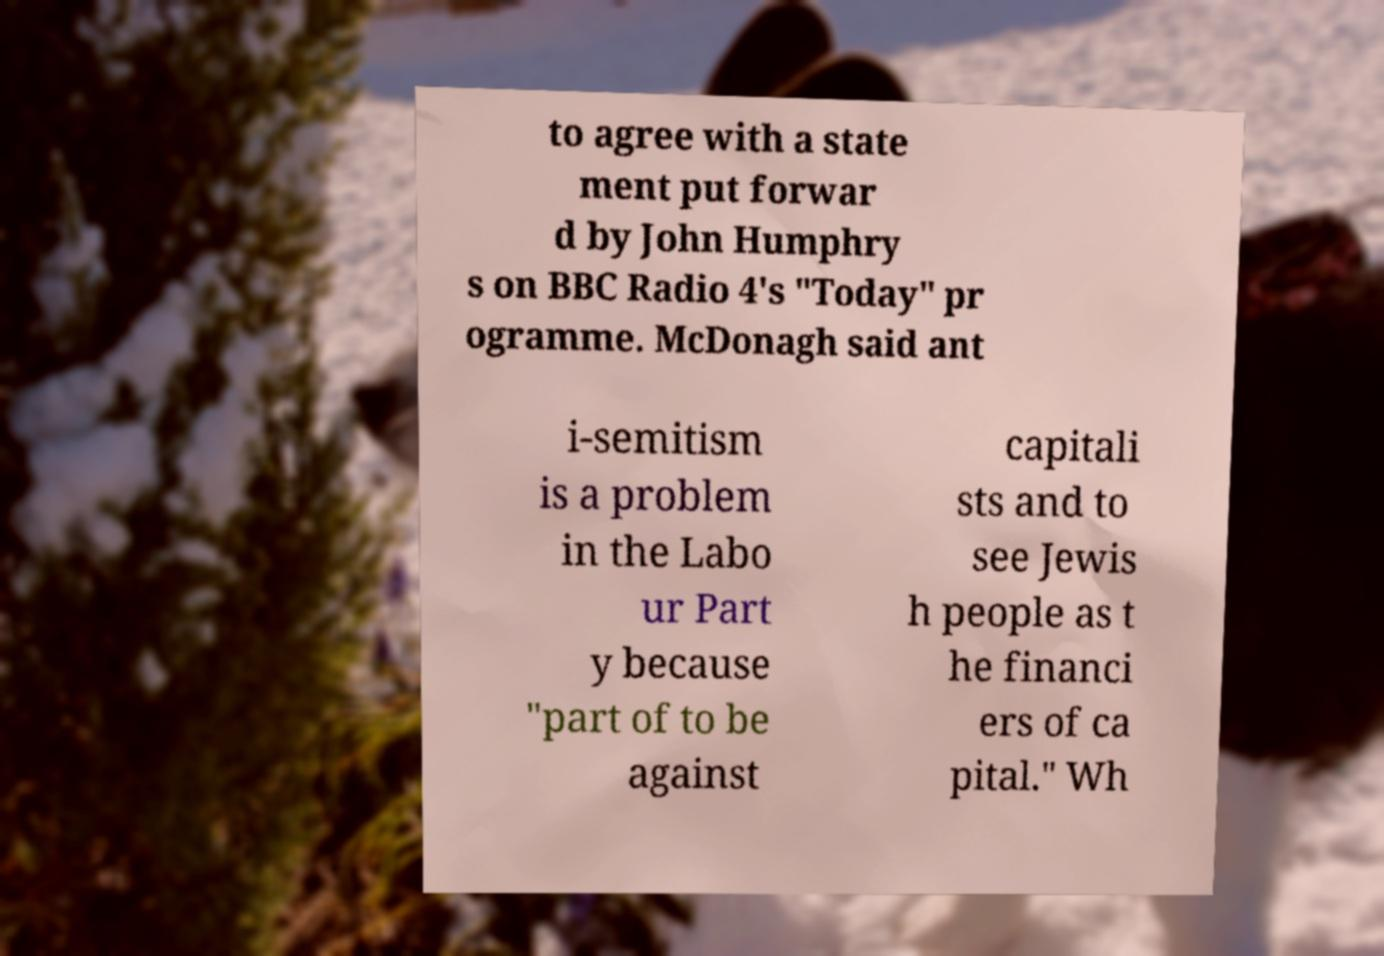There's text embedded in this image that I need extracted. Can you transcribe it verbatim? to agree with a state ment put forwar d by John Humphry s on BBC Radio 4's "Today" pr ogramme. McDonagh said ant i-semitism is a problem in the Labo ur Part y because "part of to be against capitali sts and to see Jewis h people as t he financi ers of ca pital." Wh 